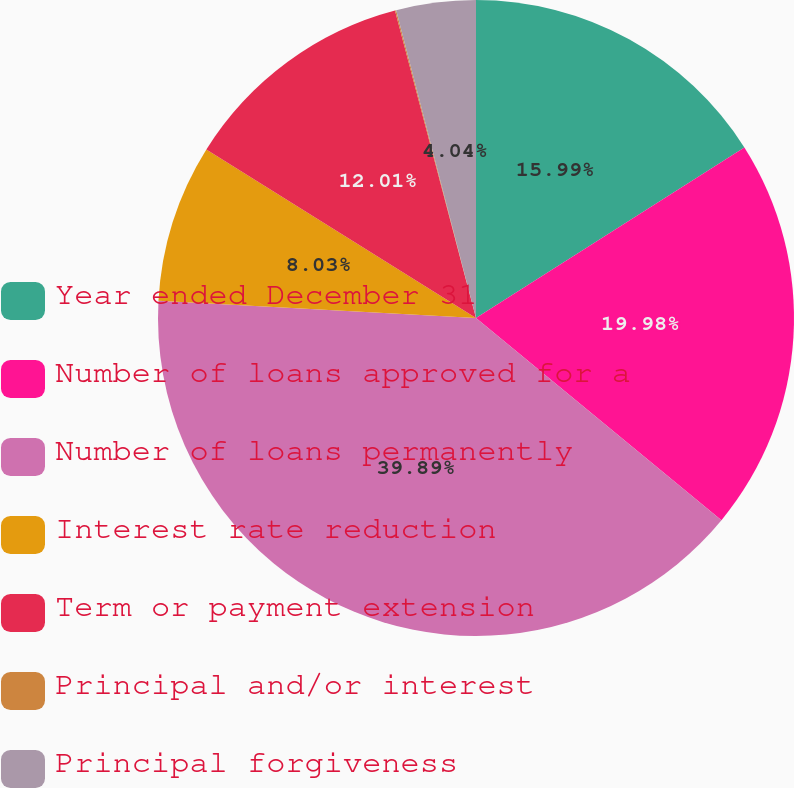Convert chart. <chart><loc_0><loc_0><loc_500><loc_500><pie_chart><fcel>Year ended December 31<fcel>Number of loans approved for a<fcel>Number of loans permanently<fcel>Interest rate reduction<fcel>Term or payment extension<fcel>Principal and/or interest<fcel>Principal forgiveness<nl><fcel>15.99%<fcel>19.98%<fcel>39.9%<fcel>8.03%<fcel>12.01%<fcel>0.06%<fcel>4.04%<nl></chart> 